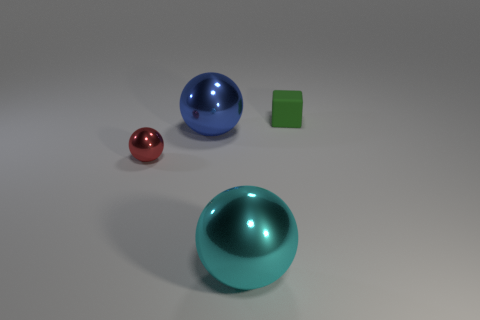How many rubber objects are either blue objects or purple cubes?
Give a very brief answer. 0. How many gray things are blocks or tiny balls?
Provide a short and direct response. 0. There is a tiny object that is in front of the tiny cube; is its color the same as the small rubber object?
Offer a very short reply. No. Does the blue thing have the same material as the tiny red object?
Provide a succinct answer. Yes. Are there the same number of tiny shiny things that are on the right side of the red shiny ball and objects on the left side of the green matte block?
Your answer should be very brief. No. There is a small red thing that is the same shape as the blue metal thing; what is it made of?
Keep it short and to the point. Metal. What shape is the big shiny object that is on the left side of the big shiny object that is in front of the shiny ball to the left of the blue metal thing?
Your response must be concise. Sphere. Are there more matte objects left of the small green rubber block than tiny green things?
Provide a succinct answer. No. Is the shape of the thing in front of the tiny metallic object the same as  the blue metal thing?
Offer a terse response. Yes. What material is the large thing that is on the right side of the blue metal thing?
Your answer should be very brief. Metal. 